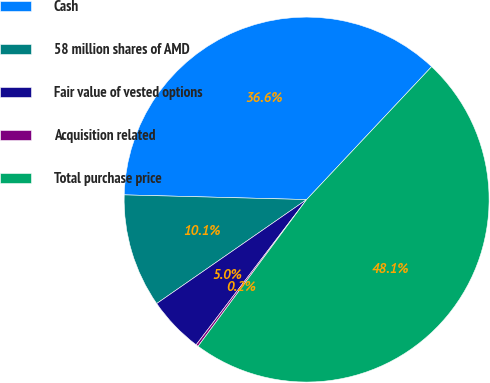Convert chart to OTSL. <chart><loc_0><loc_0><loc_500><loc_500><pie_chart><fcel>Cash<fcel>58 million shares of AMD<fcel>Fair value of vested options<fcel>Acquisition related<fcel>Total purchase price<nl><fcel>36.6%<fcel>10.06%<fcel>5.0%<fcel>0.21%<fcel>48.12%<nl></chart> 